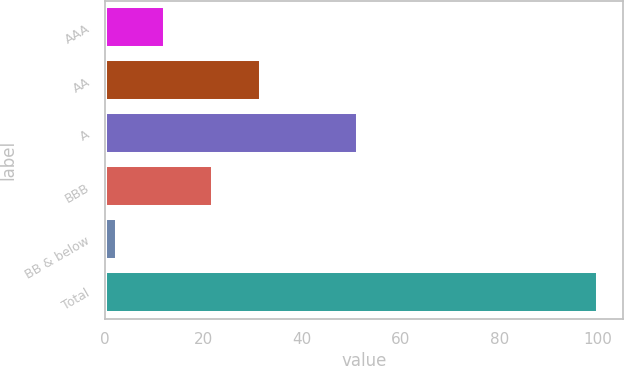Convert chart to OTSL. <chart><loc_0><loc_0><loc_500><loc_500><bar_chart><fcel>AAA<fcel>AA<fcel>A<fcel>BBB<fcel>BB & below<fcel>Total<nl><fcel>12.07<fcel>31.61<fcel>51.3<fcel>21.84<fcel>2.3<fcel>100<nl></chart> 